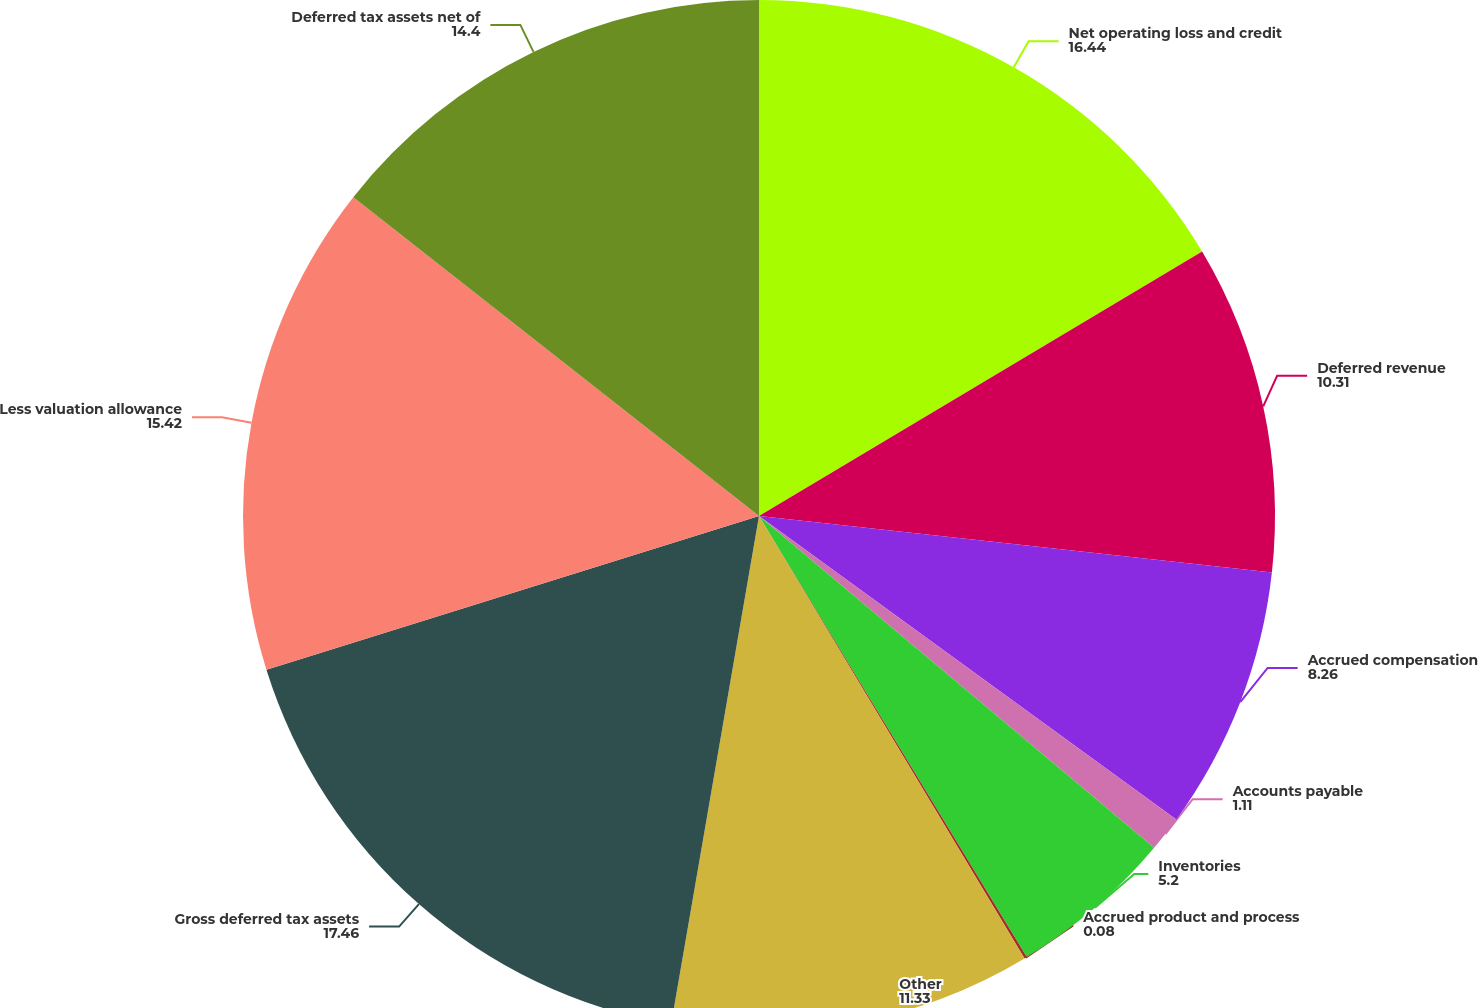<chart> <loc_0><loc_0><loc_500><loc_500><pie_chart><fcel>Net operating loss and credit<fcel>Deferred revenue<fcel>Accrued compensation<fcel>Accounts payable<fcel>Inventories<fcel>Accrued product and process<fcel>Other<fcel>Gross deferred tax assets<fcel>Less valuation allowance<fcel>Deferred tax assets net of<nl><fcel>16.44%<fcel>10.31%<fcel>8.26%<fcel>1.11%<fcel>5.2%<fcel>0.08%<fcel>11.33%<fcel>17.46%<fcel>15.42%<fcel>14.4%<nl></chart> 